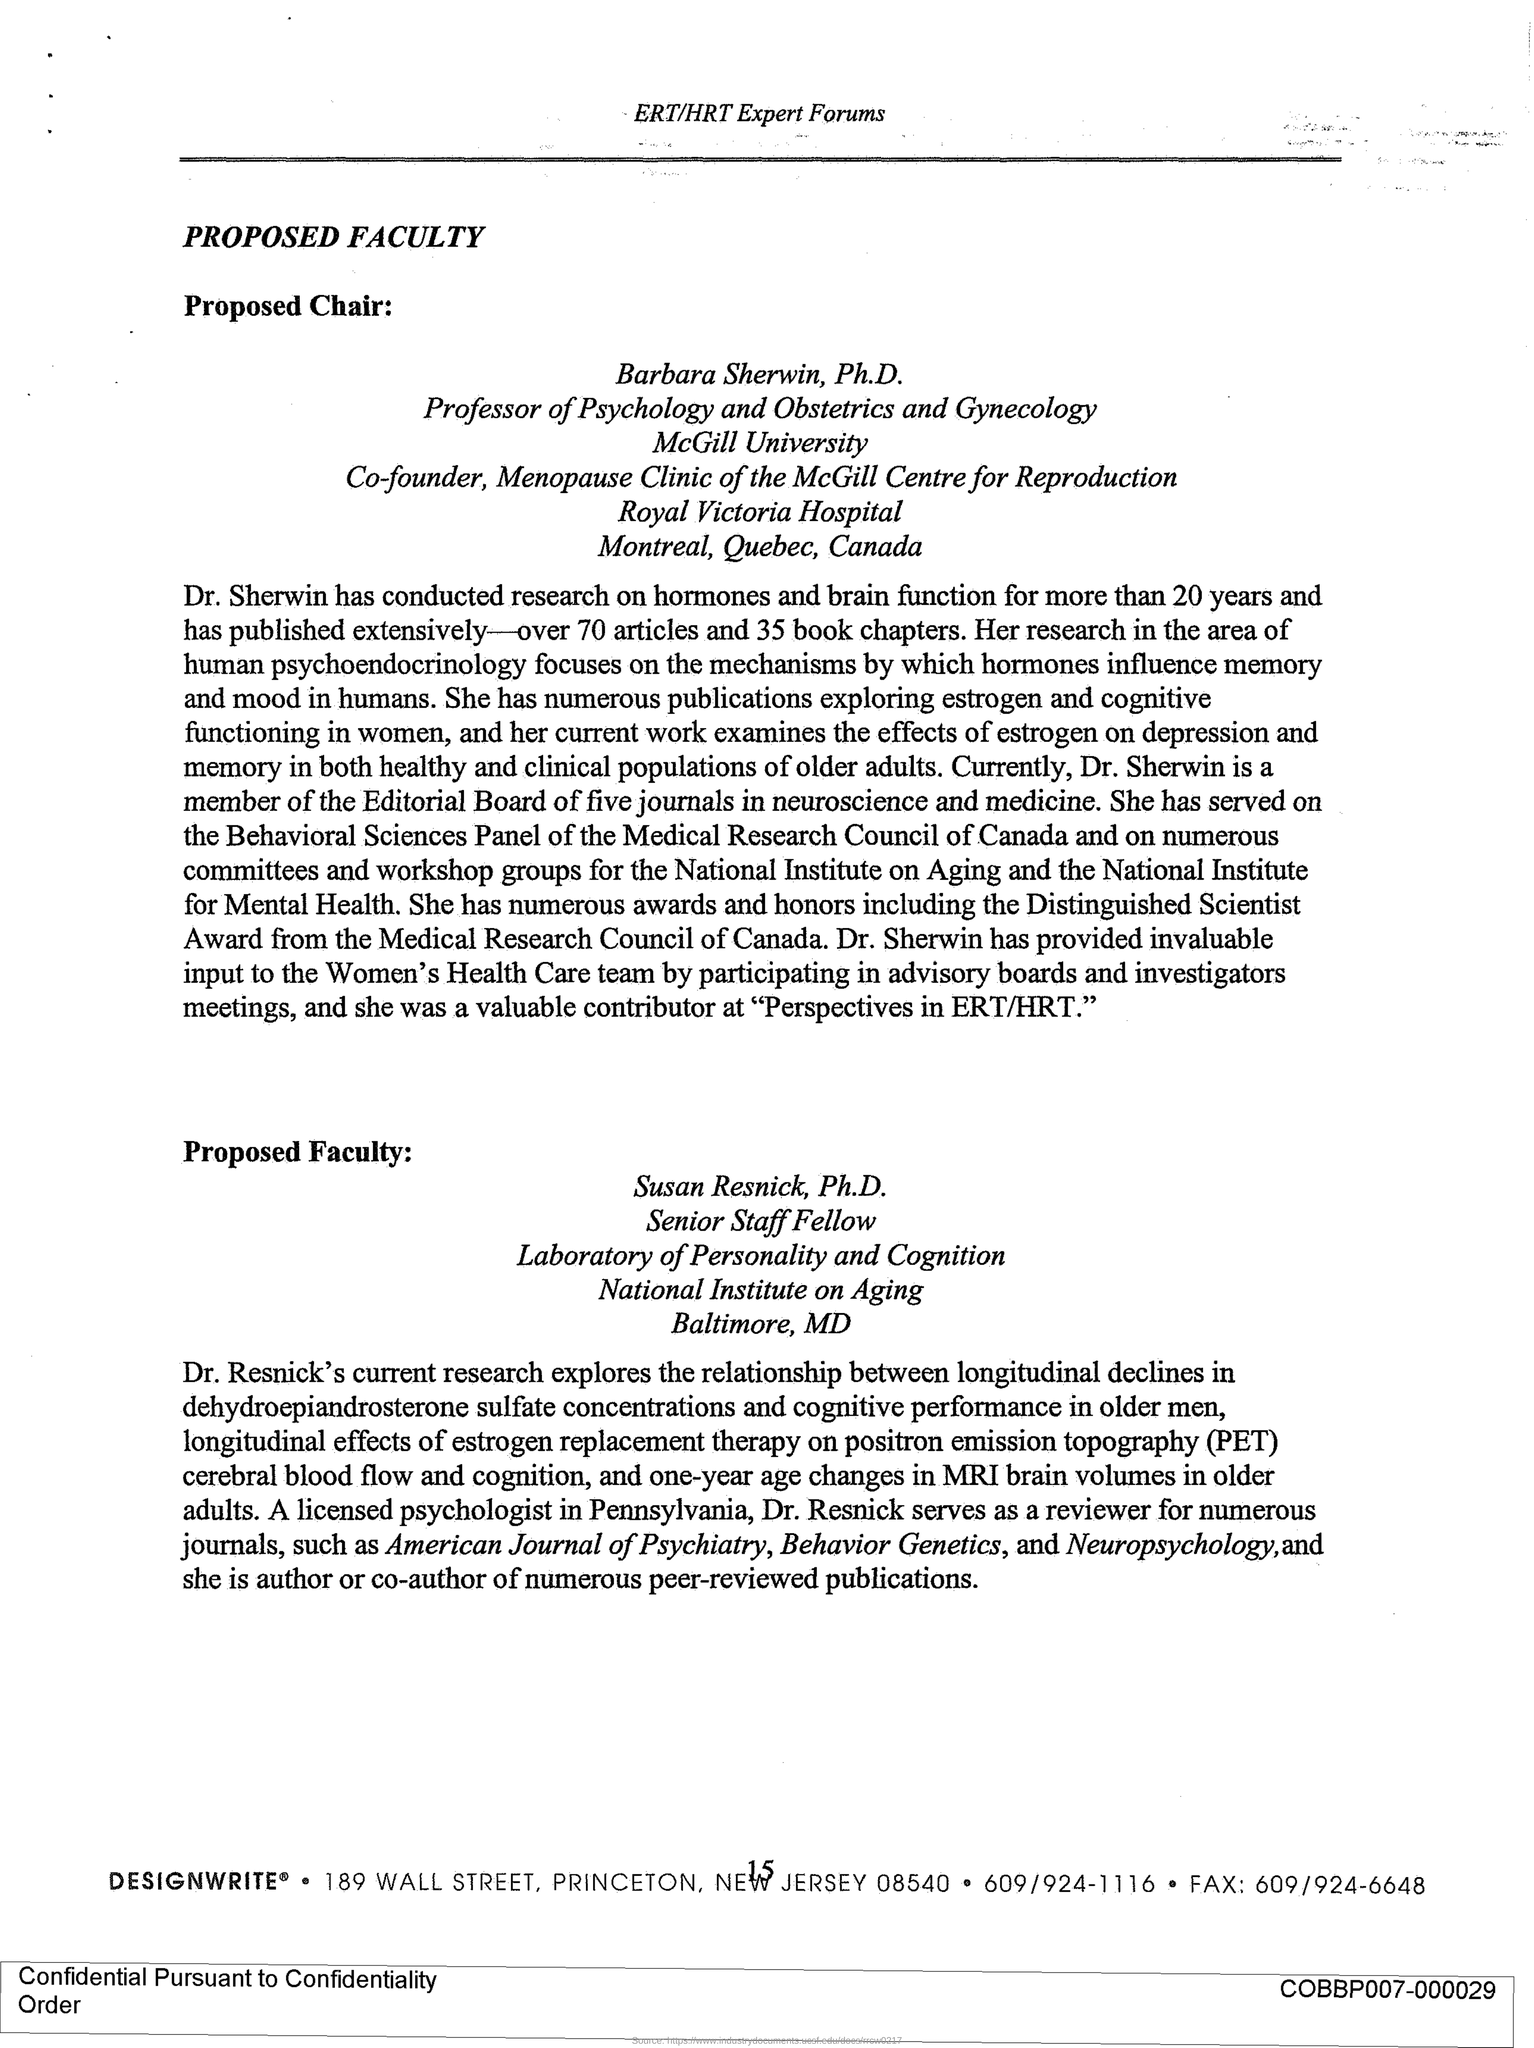Identify some key points in this picture. The document's title is PROPOSED FACULTY. Dr. Sherwin is a member of the editorial board of five journals in the field of neuroscience and medicine. Dr. Sherwin has published 35 book chapters. 